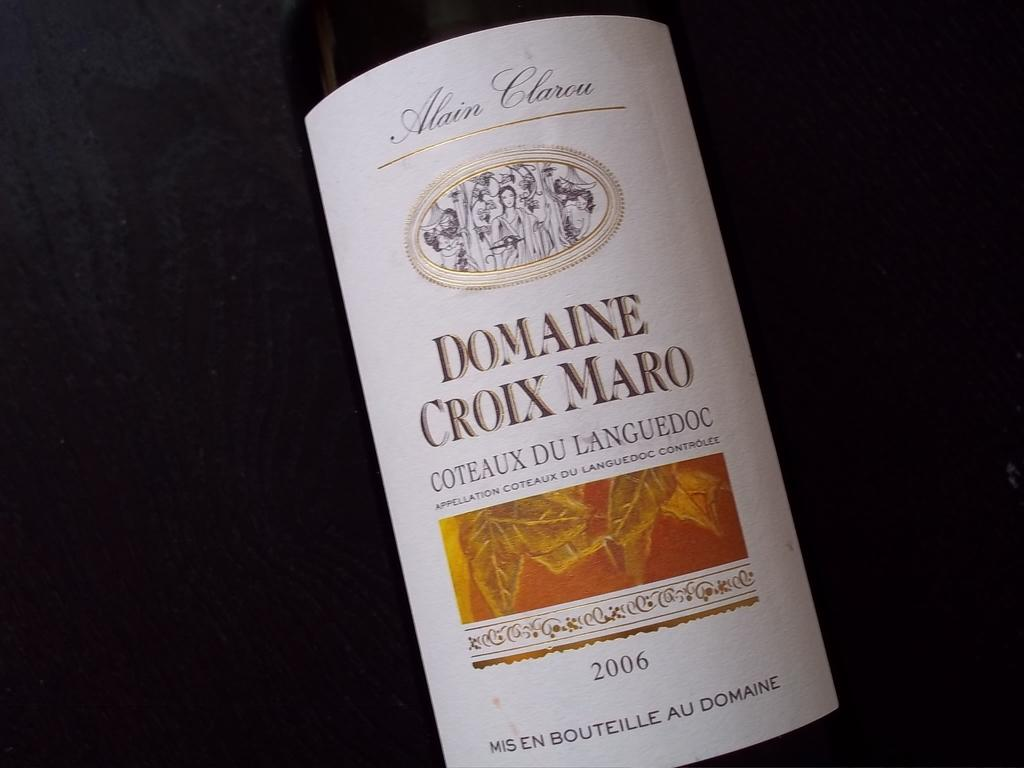<image>
Render a clear and concise summary of the photo. A Label reading Domaine Croix Maro on its face with the year on the bottom being 2006. 